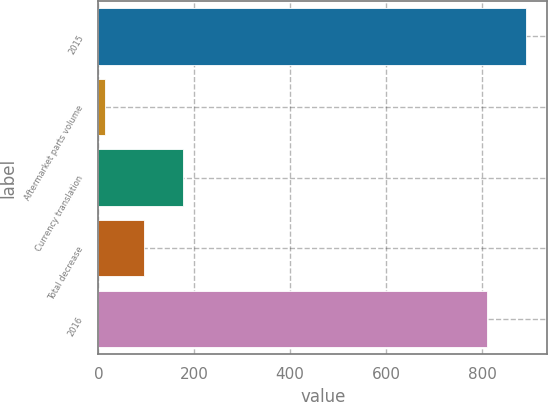Convert chart. <chart><loc_0><loc_0><loc_500><loc_500><bar_chart><fcel>2015<fcel>Aftermarket parts volume<fcel>Currency translation<fcel>Total decrease<fcel>2016<nl><fcel>891.36<fcel>14.1<fcel>176.82<fcel>95.46<fcel>810<nl></chart> 